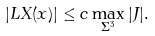<formula> <loc_0><loc_0><loc_500><loc_500>| L X ( x ) | \leq c \max _ { \Sigma ^ { 3 } } | J | .</formula> 